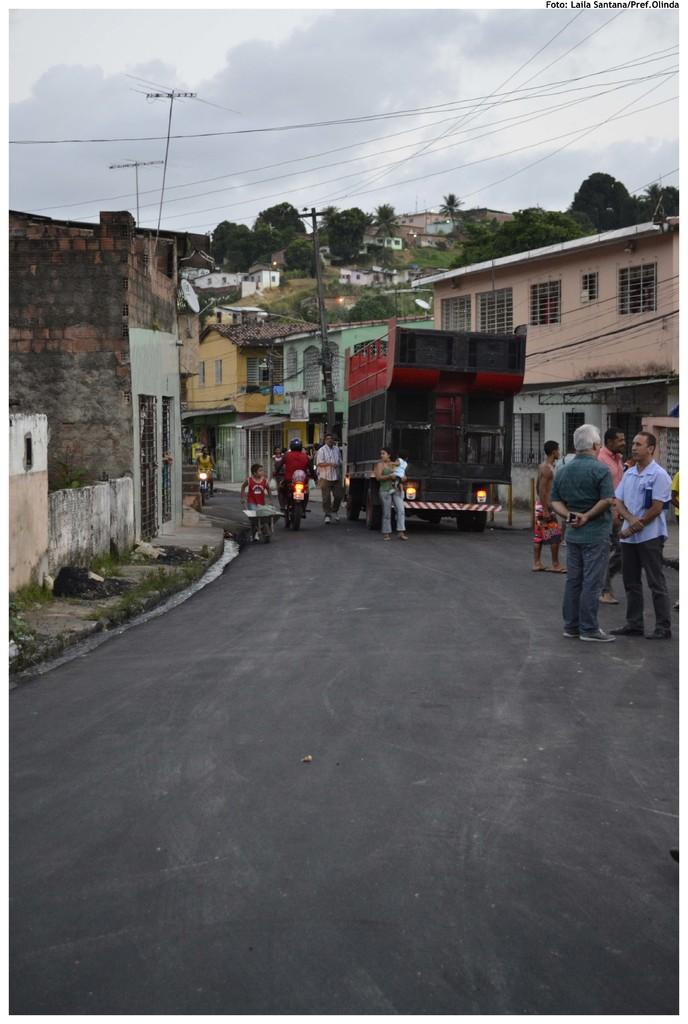What can be seen on the road in the image? There are vehicles on the road in the image. Who or what else is present in the image? There are people in the image. What can be seen in the distance in the image? There are buildings, poles, trees, wires, and the sky visible in the background of the image. What type of cork can be seen in the image? There is no cork present in the image. How does the eggnog react to the shock in the image? There is no eggnog or shock present in the image. 